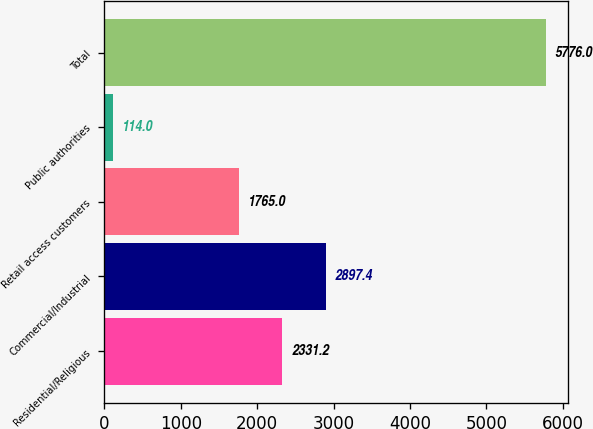Convert chart. <chart><loc_0><loc_0><loc_500><loc_500><bar_chart><fcel>Residential/Religious<fcel>Commercial/Industrial<fcel>Retail access customers<fcel>Public authorities<fcel>Total<nl><fcel>2331.2<fcel>2897.4<fcel>1765<fcel>114<fcel>5776<nl></chart> 